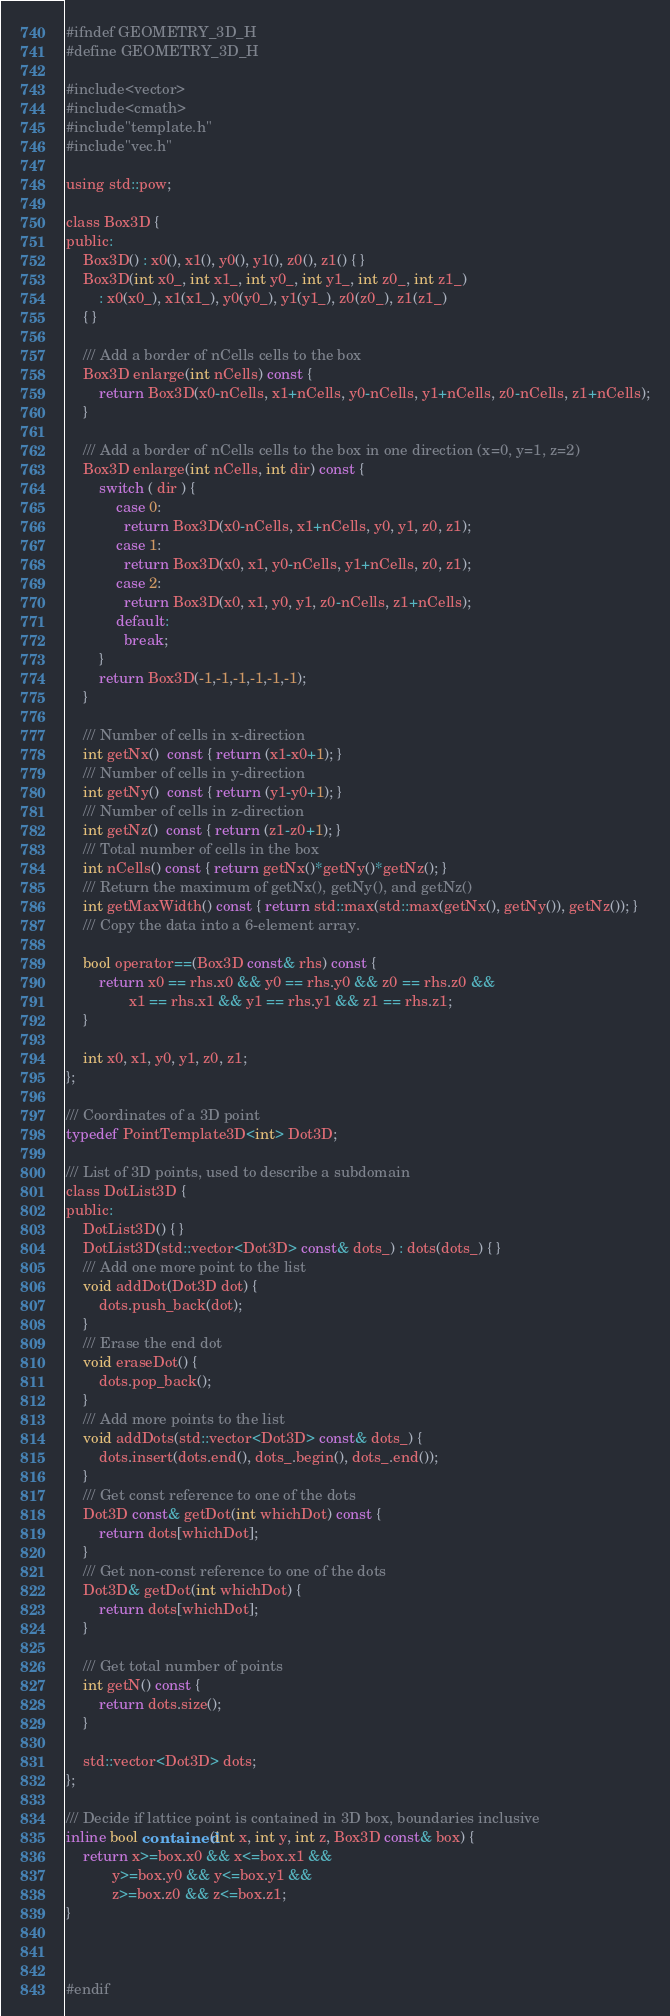<code> <loc_0><loc_0><loc_500><loc_500><_C_>#ifndef GEOMETRY_3D_H
#define GEOMETRY_3D_H

#include<vector>
#include<cmath>
#include"template.h"
#include"vec.h"

using std::pow;

class Box3D {
public:
    Box3D() : x0(), x1(), y0(), y1(), z0(), z1() { }
    Box3D(int x0_, int x1_, int y0_, int y1_, int z0_, int z1_)
        : x0(x0_), x1(x1_), y0(y0_), y1(y1_), z0(z0_), z1(z1_)
    { }

    /// Add a border of nCells cells to the box
    Box3D enlarge(int nCells) const {
        return Box3D(x0-nCells, x1+nCells, y0-nCells, y1+nCells, z0-nCells, z1+nCells);
    }

    /// Add a border of nCells cells to the box in one direction (x=0, y=1, z=2)
    Box3D enlarge(int nCells, int dir) const {
        switch ( dir ) {
            case 0:
              return Box3D(x0-nCells, x1+nCells, y0, y1, z0, z1);
            case 1:
              return Box3D(x0, x1, y0-nCells, y1+nCells, z0, z1);
            case 2:
              return Box3D(x0, x1, y0, y1, z0-nCells, z1+nCells);
            default:
              break;
        }
        return Box3D(-1,-1,-1,-1,-1,-1);
    }

    /// Number of cells in x-direction
    int getNx()  const { return (x1-x0+1); }
    /// Number of cells in y-direction
    int getNy()  const { return (y1-y0+1); }
    /// Number of cells in z-direction
    int getNz()  const { return (z1-z0+1); }
    /// Total number of cells in the box
    int nCells() const { return getNx()*getNy()*getNz(); }
    /// Return the maximum of getNx(), getNy(), and getNz()
    int getMaxWidth() const { return std::max(std::max(getNx(), getNy()), getNz()); }
    /// Copy the data into a 6-element array.

    bool operator==(Box3D const& rhs) const {
        return x0 == rhs.x0 && y0 == rhs.y0 && z0 == rhs.z0 &&
               x1 == rhs.x1 && y1 == rhs.y1 && z1 == rhs.z1;
    }

    int x0, x1, y0, y1, z0, z1;
};

/// Coordinates of a 3D point
typedef PointTemplate3D<int> Dot3D;

/// List of 3D points, used to describe a subdomain
class DotList3D {
public:
    DotList3D() { }
    DotList3D(std::vector<Dot3D> const& dots_) : dots(dots_) { }
    /// Add one more point to the list
    void addDot(Dot3D dot) {
        dots.push_back(dot);
    }
    /// Erase the end dot
    void eraseDot() {
        dots.pop_back();
    }
    /// Add more points to the list
    void addDots(std::vector<Dot3D> const& dots_) {
        dots.insert(dots.end(), dots_.begin(), dots_.end());
    }
    /// Get const reference to one of the dots
    Dot3D const& getDot(int whichDot) const {
        return dots[whichDot];
    }
    /// Get non-const reference to one of the dots
    Dot3D& getDot(int whichDot) {
        return dots[whichDot];
    }

    /// Get total number of points
    int getN() const {
        return dots.size();
    }

    std::vector<Dot3D> dots;
};

/// Decide if lattice point is contained in 3D box, boundaries inclusive
inline bool contained(int x, int y, int z, Box3D const& box) {
    return x>=box.x0 && x<=box.x1 &&
           y>=box.y0 && y<=box.y1 &&
           z>=box.z0 && z<=box.z1;
}



#endif</code> 